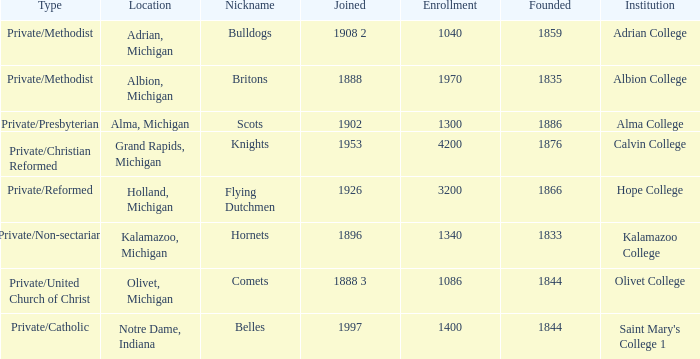Which categories fit under the institution calvin college? Private/Christian Reformed. 